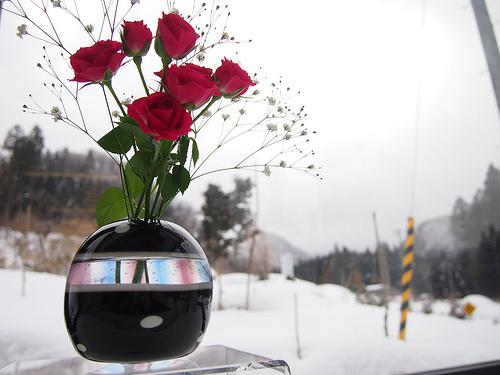Question: what are the flowers in?
Choices:
A. A vase.
B. Pot.
C. Bowl.
D. Tumbler.
Answer with the letter. Answer: A Question: who is visible?
Choices:
A. Baseball players.
B. Cheerleaders.
C. No one.
D. Snowboarders.
Answer with the letter. Answer: C Question: what time is it?
Choices:
A. Nighttime.
B. Dusk.
C. Daytime.
D. 3:10.
Answer with the letter. Answer: C Question: what is outside?
Choices:
A. Rain.
B. Snow.
C. Fog.
D. Grass.
Answer with the letter. Answer: B Question: how many roses are there?
Choices:
A. Seven.
B. Five.
C. Three.
D. Six.
Answer with the letter. Answer: D 